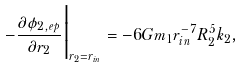Convert formula to latex. <formula><loc_0><loc_0><loc_500><loc_500>- \frac { \partial \phi _ { 2 , e p } } { \partial r _ { 2 } } \Big { | } _ { r _ { 2 } = r _ { i n } } = - 6 G m _ { 1 } r _ { i n } ^ { - 7 } R _ { 2 } ^ { 5 } k _ { 2 } ,</formula> 